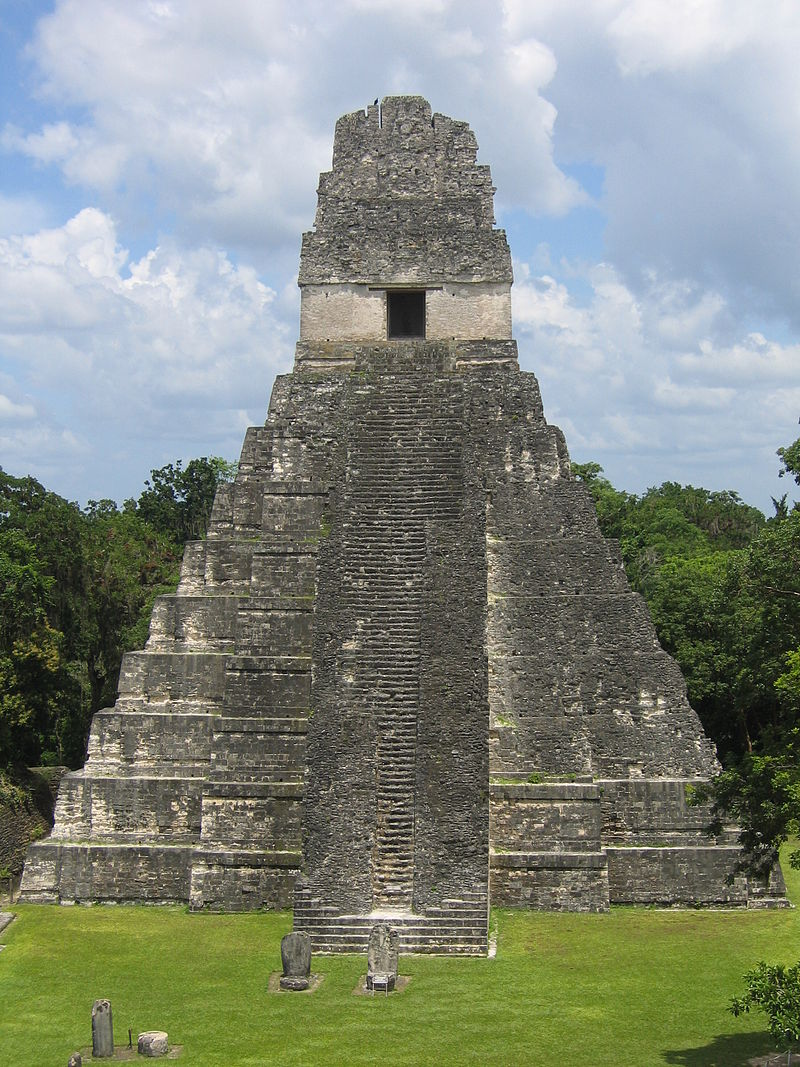Can you describe the historical context of Tikal Temple I? Certainly! Tikal Temple I, constructed around 732 AD, is one of the most iconic structures of the ancient Mayan civilization. It was commissioned by the eighth ruler of Tikal, Jasaw Chan K'awiil I, who intended it as both a testament to his reign and as his final resting place. The temple is emblematic of the Classic Period of Mayan history, a time marked by extensive building projects and flourishing city-states. Its architecture reflects both religious and political significance, serving as a center for ceremonial activities and symbolizing the connection between the gods, the ruler, and the people. 